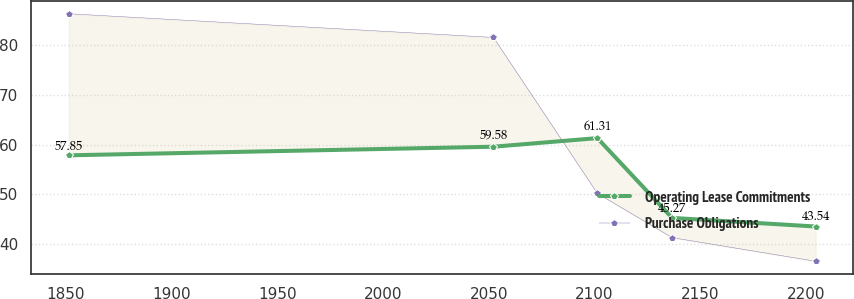<chart> <loc_0><loc_0><loc_500><loc_500><line_chart><ecel><fcel>Operating Lease Commitments<fcel>Purchase Obligations<nl><fcel>1851.47<fcel>57.85<fcel>86.31<nl><fcel>2052.21<fcel>59.58<fcel>81.55<nl><fcel>2101.37<fcel>61.31<fcel>50.19<nl><fcel>2136.68<fcel>45.27<fcel>41.31<nl><fcel>2204.54<fcel>43.54<fcel>36.55<nl></chart> 